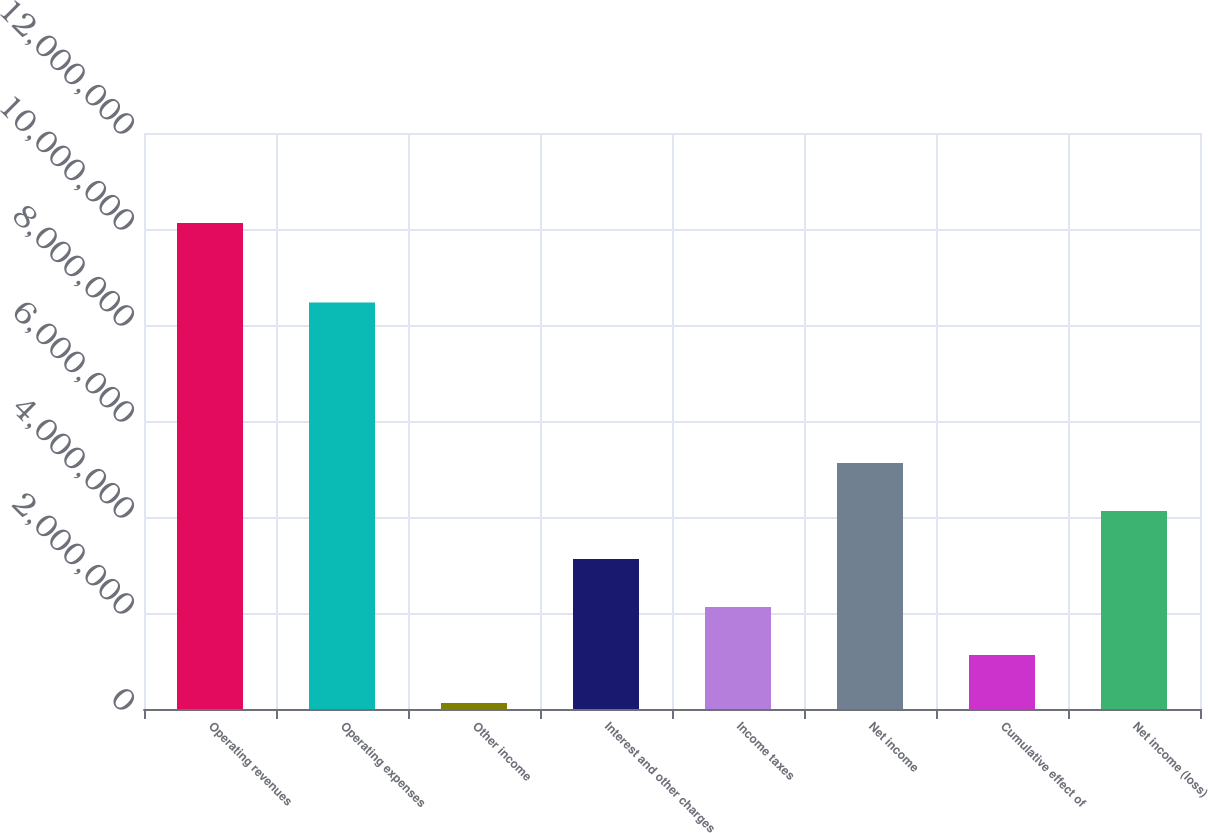<chart> <loc_0><loc_0><loc_500><loc_500><bar_chart><fcel>Operating revenues<fcel>Operating expenses<fcel>Other income<fcel>Interest and other charges<fcel>Income taxes<fcel>Net income<fcel>Cumulative effect of<fcel>Net income (loss)<nl><fcel>1.01237e+07<fcel>8.47016e+06<fcel>124416<fcel>3.12421e+06<fcel>2.12428e+06<fcel>5.12407e+06<fcel>1.12435e+06<fcel>4.12414e+06<nl></chart> 